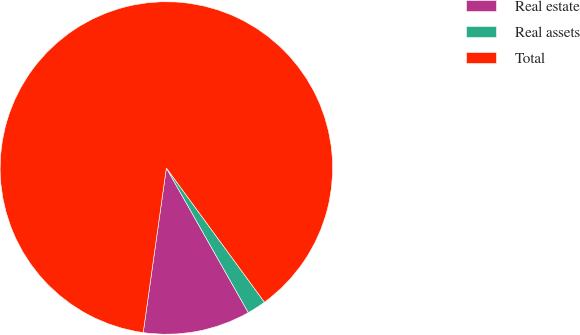Convert chart. <chart><loc_0><loc_0><loc_500><loc_500><pie_chart><fcel>Real estate<fcel>Real assets<fcel>Total<nl><fcel>10.43%<fcel>1.84%<fcel>87.73%<nl></chart> 